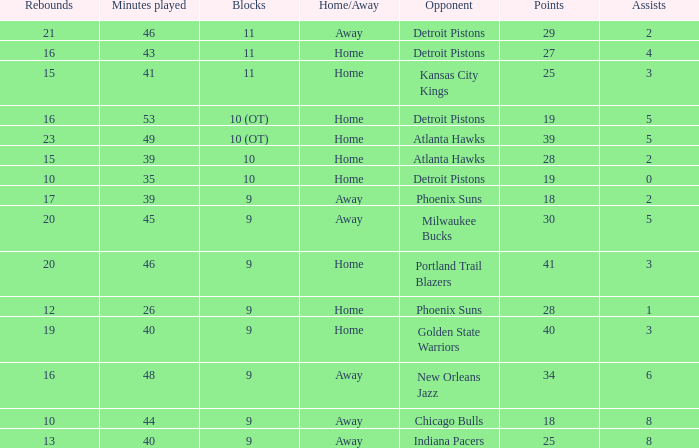How many points were there when there were less than 16 rebounds and 5 assists? 0.0. Could you help me parse every detail presented in this table? {'header': ['Rebounds', 'Minutes played', 'Blocks', 'Home/Away', 'Opponent', 'Points', 'Assists'], 'rows': [['21', '46', '11', 'Away', 'Detroit Pistons', '29', '2'], ['16', '43', '11', 'Home', 'Detroit Pistons', '27', '4'], ['15', '41', '11', 'Home', 'Kansas City Kings', '25', '3'], ['16', '53', '10 (OT)', 'Home', 'Detroit Pistons', '19', '5'], ['23', '49', '10 (OT)', 'Home', 'Atlanta Hawks', '39', '5'], ['15', '39', '10', 'Home', 'Atlanta Hawks', '28', '2'], ['10', '35', '10', 'Home', 'Detroit Pistons', '19', '0'], ['17', '39', '9', 'Away', 'Phoenix Suns', '18', '2'], ['20', '45', '9', 'Away', 'Milwaukee Bucks', '30', '5'], ['20', '46', '9', 'Home', 'Portland Trail Blazers', '41', '3'], ['12', '26', '9', 'Home', 'Phoenix Suns', '28', '1'], ['19', '40', '9', 'Home', 'Golden State Warriors', '40', '3'], ['16', '48', '9', 'Away', 'New Orleans Jazz', '34', '6'], ['10', '44', '9', 'Away', 'Chicago Bulls', '18', '8'], ['13', '40', '9', 'Away', 'Indiana Pacers', '25', '8']]} 